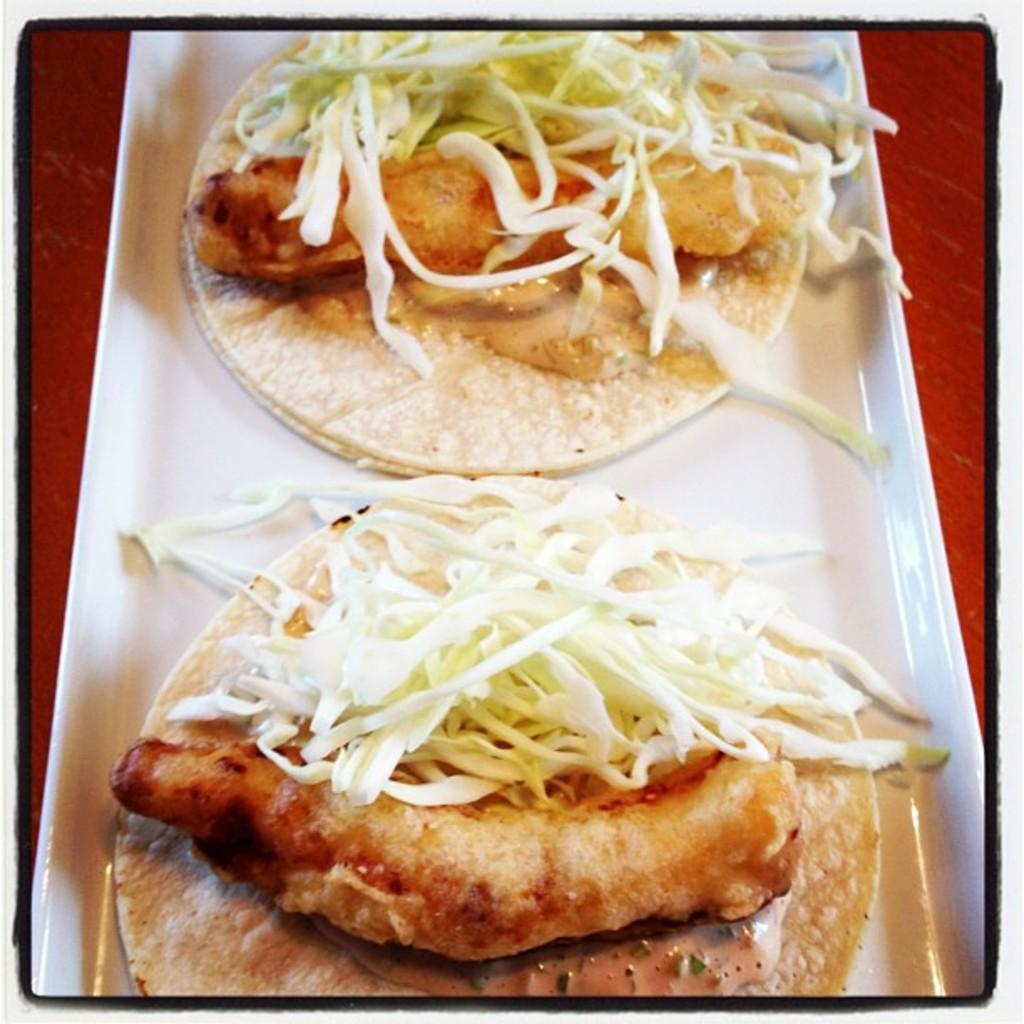What can be seen on the plate in the image? There is a food item on the plate in the image. Can you describe the plate itself? The facts provided do not give any details about the plate, so we cannot describe it further. Is there a veil hanging in the room or office shown in the image? The image does not show a room or office, nor does it depict a veil. 